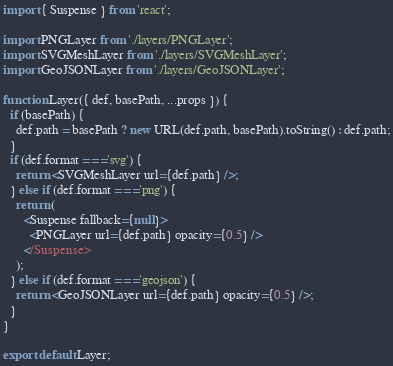<code> <loc_0><loc_0><loc_500><loc_500><_JavaScript_>import { Suspense } from 'react';

import PNGLayer from './layers/PNGLayer';
import SVGMeshLayer from './layers/SVGMeshLayer';
import GeoJSONLayer from './layers/GeoJSONLayer';

function Layer({ def, basePath, ...props }) {
  if (basePath) {
    def.path = basePath ? new URL(def.path, basePath).toString() : def.path;
  }
  if (def.format === 'svg') {
    return <SVGMeshLayer url={def.path} />;
  } else if (def.format === 'png') {
    return (
      <Suspense fallback={null}>
        <PNGLayer url={def.path} opacity={0.5} />
      </Suspense>
    );
  } else if (def.format === 'geojson') {
    return <GeoJSONLayer url={def.path} opacity={0.5} />;
  }
}

export default Layer;
</code> 